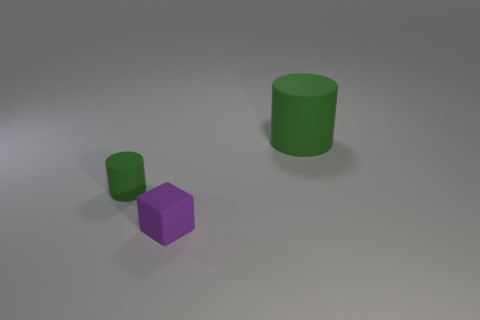Is the number of purple objects that are behind the large green cylinder greater than the number of green rubber things that are on the left side of the tiny green rubber thing?
Give a very brief answer. No. Do the green cylinder that is on the left side of the block and the cylinder to the right of the purple rubber thing have the same material?
Provide a short and direct response. Yes. Is there another tiny purple rubber thing that has the same shape as the tiny purple thing?
Your answer should be very brief. No. Do the rubber thing that is right of the purple matte block and the small thing on the left side of the tiny purple rubber thing have the same color?
Make the answer very short. Yes. Are there any large cylinders behind the purple matte cube?
Make the answer very short. Yes. What is the object that is right of the tiny green rubber thing and behind the rubber cube made of?
Your response must be concise. Rubber. Do the thing in front of the tiny green object and the big green object have the same material?
Your response must be concise. Yes. What is the material of the small purple block?
Your answer should be very brief. Rubber. How big is the cylinder right of the purple matte cube?
Make the answer very short. Large. Are there any other things that are the same color as the big thing?
Provide a succinct answer. Yes. 